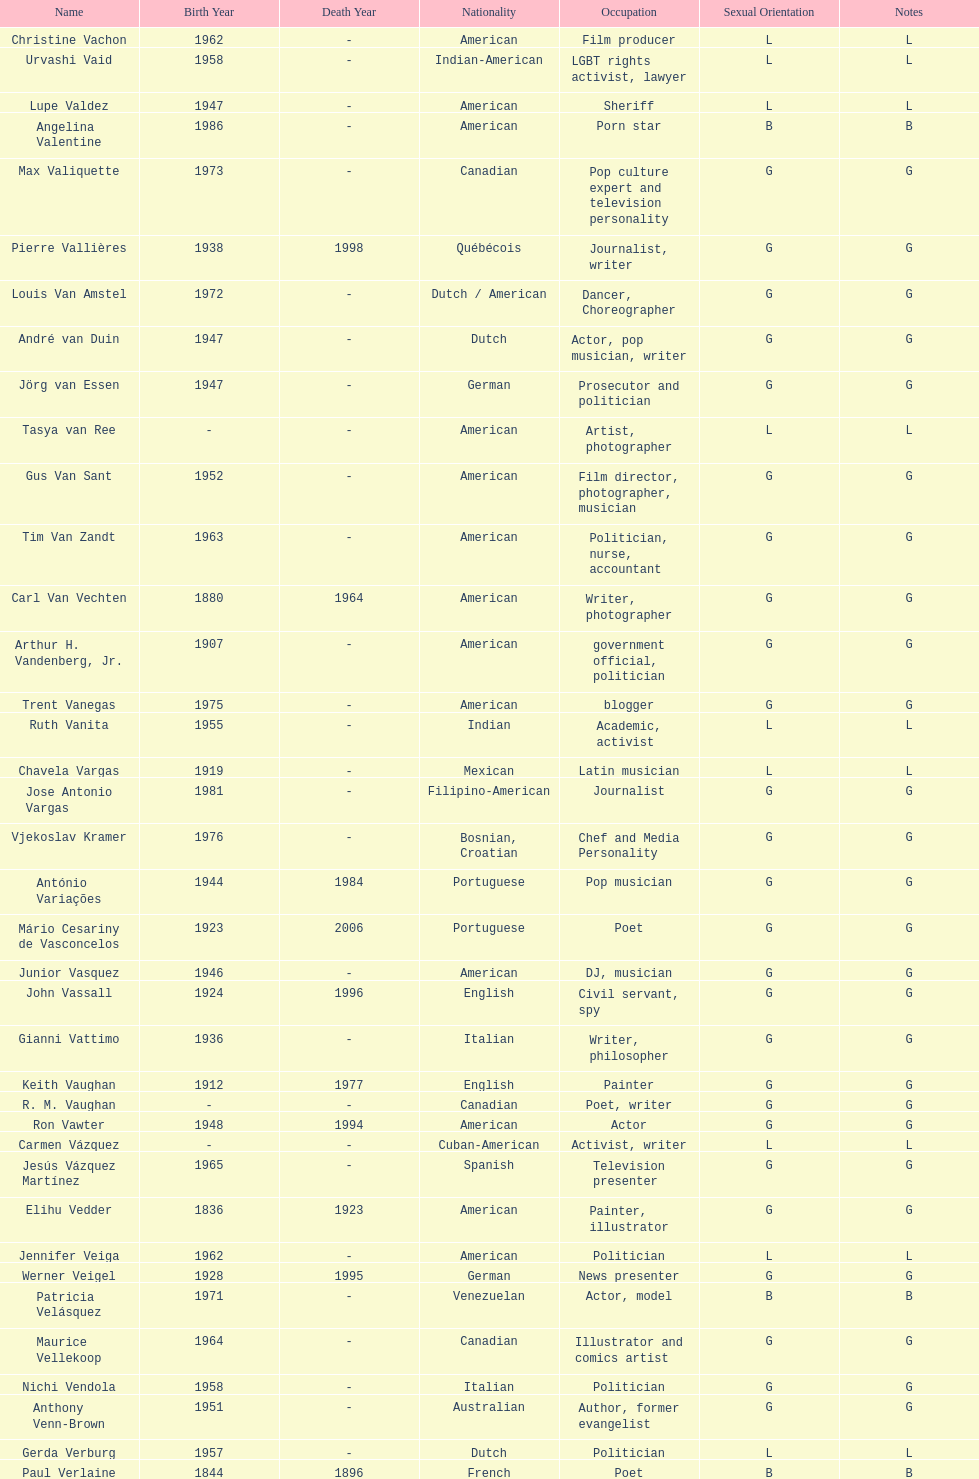Which nationality has the most people associated with it? American. 